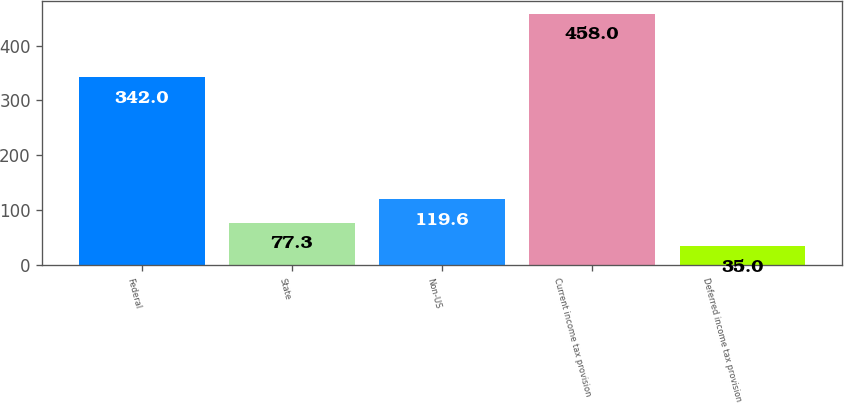Convert chart to OTSL. <chart><loc_0><loc_0><loc_500><loc_500><bar_chart><fcel>Federal<fcel>State<fcel>Non-US<fcel>Current income tax provision<fcel>Deferred income tax provision<nl><fcel>342<fcel>77.3<fcel>119.6<fcel>458<fcel>35<nl></chart> 